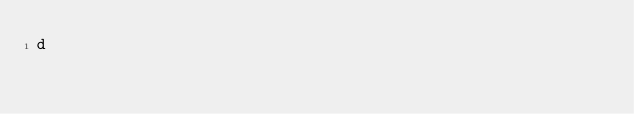<code> <loc_0><loc_0><loc_500><loc_500><_C++_>d</code> 